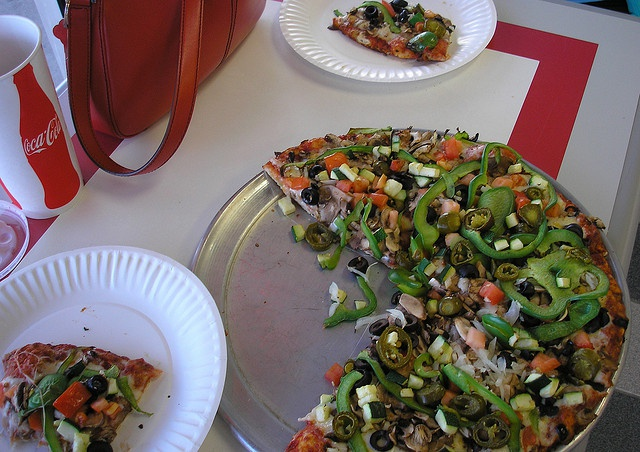Describe the objects in this image and their specific colors. I can see pizza in gray, black, olive, and maroon tones, dining table in gray, darkgray, and brown tones, handbag in gray, maroon, black, and brown tones, pizza in gray, black, maroon, and olive tones, and cup in gray, maroon, and darkgray tones in this image. 